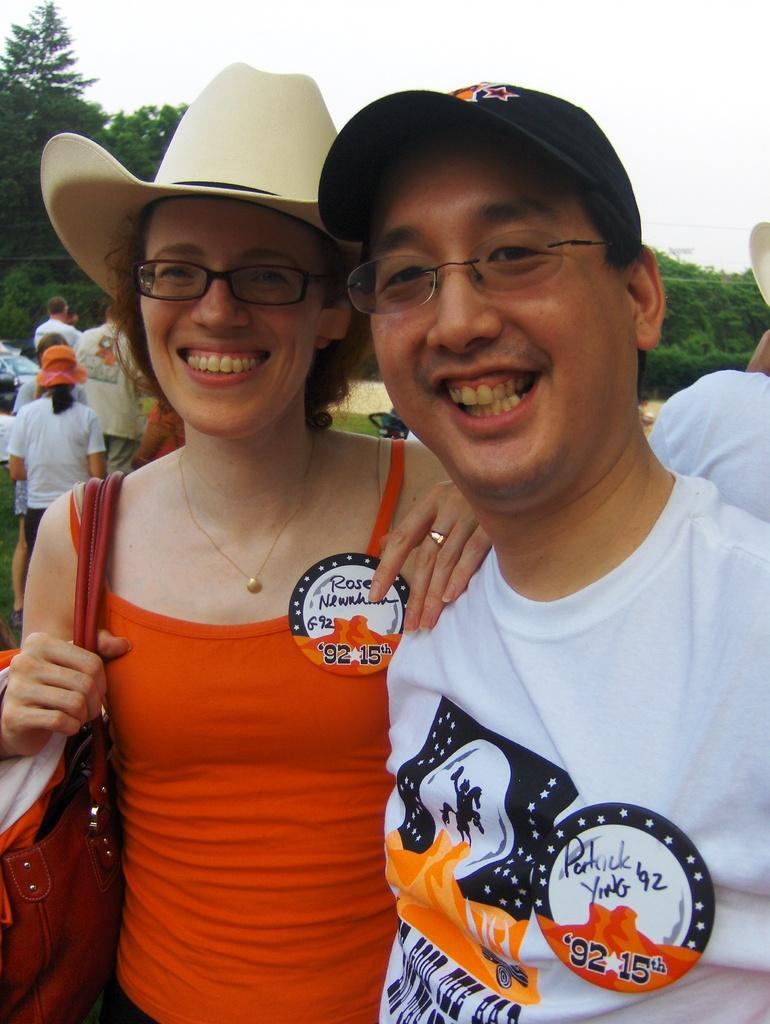Please provide a concise description of this image. In this picture I can see few people are standing and few of them are wearing caps on their heads and couple of them are wearing spectacles and I can see trees and I can see a woman is wearing handbags and a cloudy sky. 